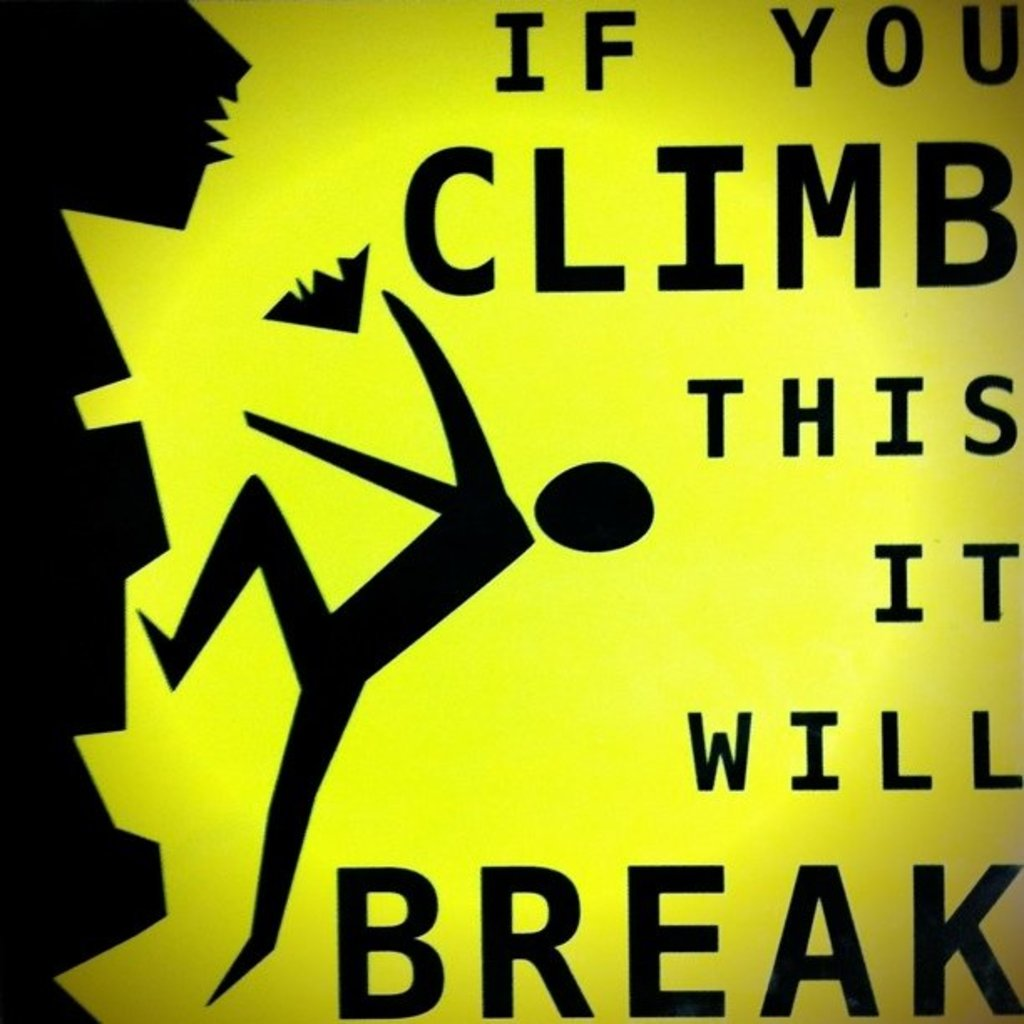Explain the visual content of the image in great detail.
 The image features a warning sign that is designed to deter people from climbing a certain structure. The sign is characterized by a black silhouette of a person climbing, set against a yellow background. The text on the sign clearly states "If you climb this it will break", indicating that the structure is not sturdy enough to support the weight of a person and may break if someone attempts to climb it. This sign serves as a cautionary message to prevent potential accidents and damage. 